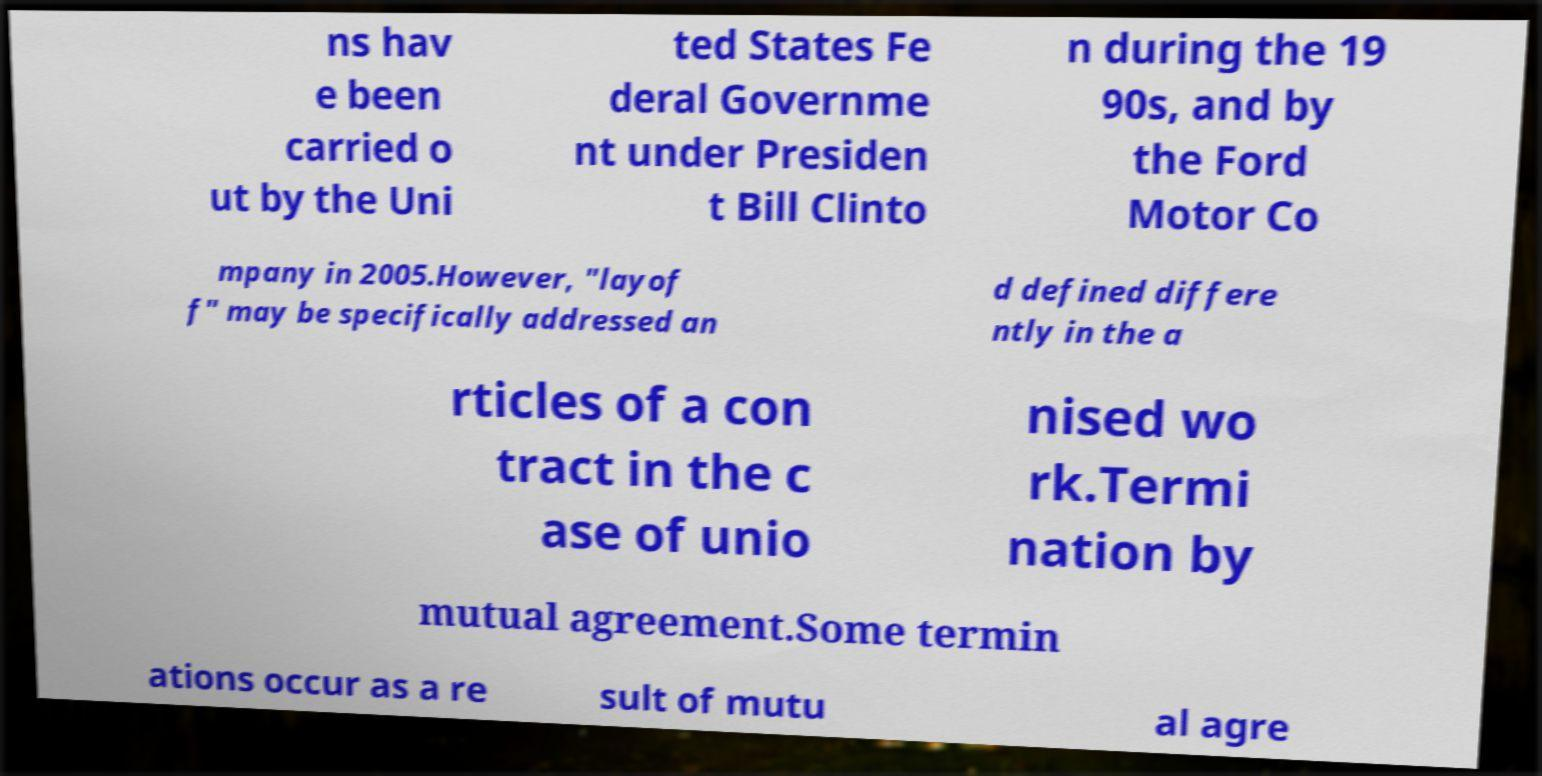Can you accurately transcribe the text from the provided image for me? ns hav e been carried o ut by the Uni ted States Fe deral Governme nt under Presiden t Bill Clinto n during the 19 90s, and by the Ford Motor Co mpany in 2005.However, "layof f" may be specifically addressed an d defined differe ntly in the a rticles of a con tract in the c ase of unio nised wo rk.Termi nation by mutual agreement.Some termin ations occur as a re sult of mutu al agre 